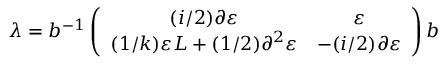Convert formula to latex. <formula><loc_0><loc_0><loc_500><loc_500>\lambda = b ^ { - 1 } \left ( \begin{array} { c c } { ( i / 2 ) \partial \varepsilon } & { \varepsilon } \\ { { ( 1 / k ) \varepsilon L + ( 1 / 2 ) \partial ^ { 2 } \varepsilon } } & { - ( i / 2 ) \partial \varepsilon } \end{array} \right ) b</formula> 